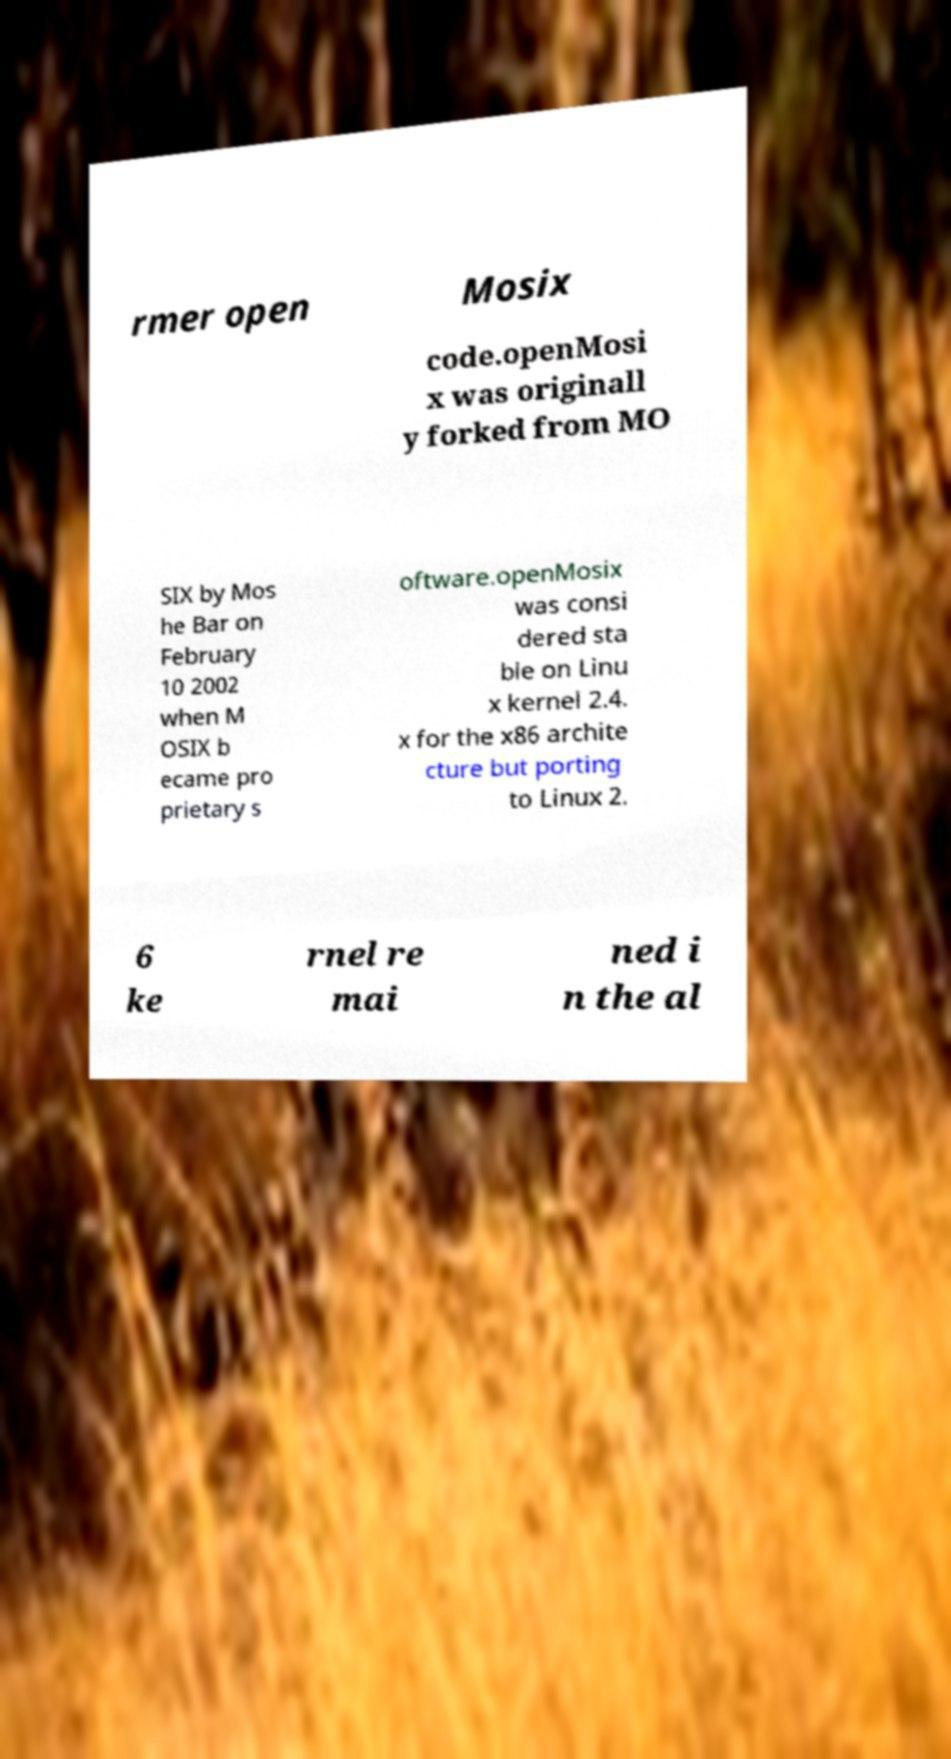Can you accurately transcribe the text from the provided image for me? rmer open Mosix code.openMosi x was originall y forked from MO SIX by Mos he Bar on February 10 2002 when M OSIX b ecame pro prietary s oftware.openMosix was consi dered sta ble on Linu x kernel 2.4. x for the x86 archite cture but porting to Linux 2. 6 ke rnel re mai ned i n the al 